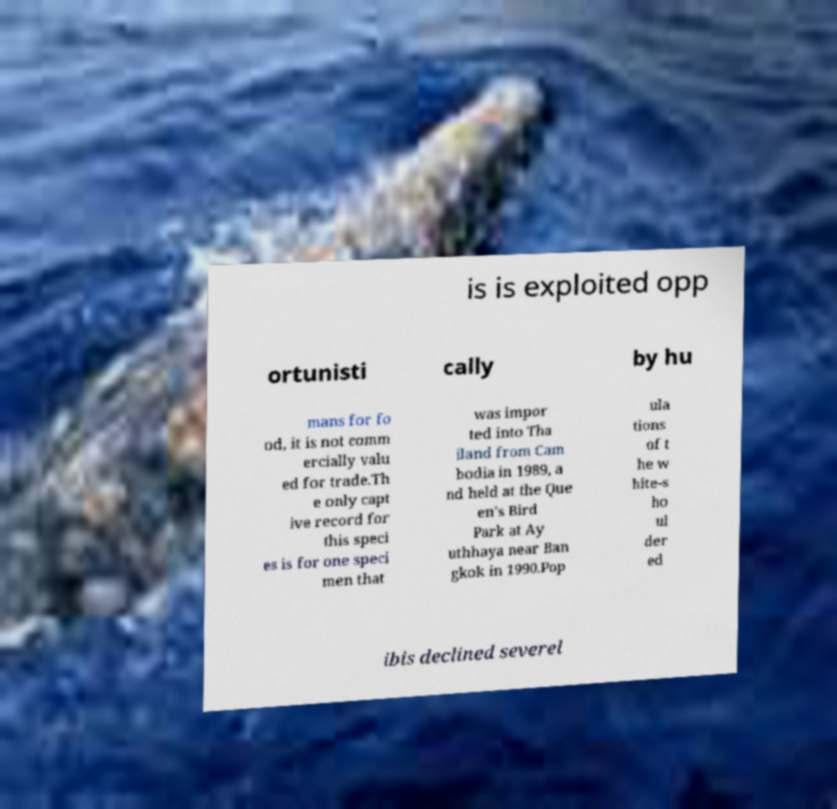What messages or text are displayed in this image? I need them in a readable, typed format. is is exploited opp ortunisti cally by hu mans for fo od, it is not comm ercially valu ed for trade.Th e only capt ive record for this speci es is for one speci men that was impor ted into Tha iland from Cam bodia in 1989, a nd held at the Que en's Bird Park at Ay uthhaya near Ban gkok in 1990.Pop ula tions of t he w hite-s ho ul der ed ibis declined severel 